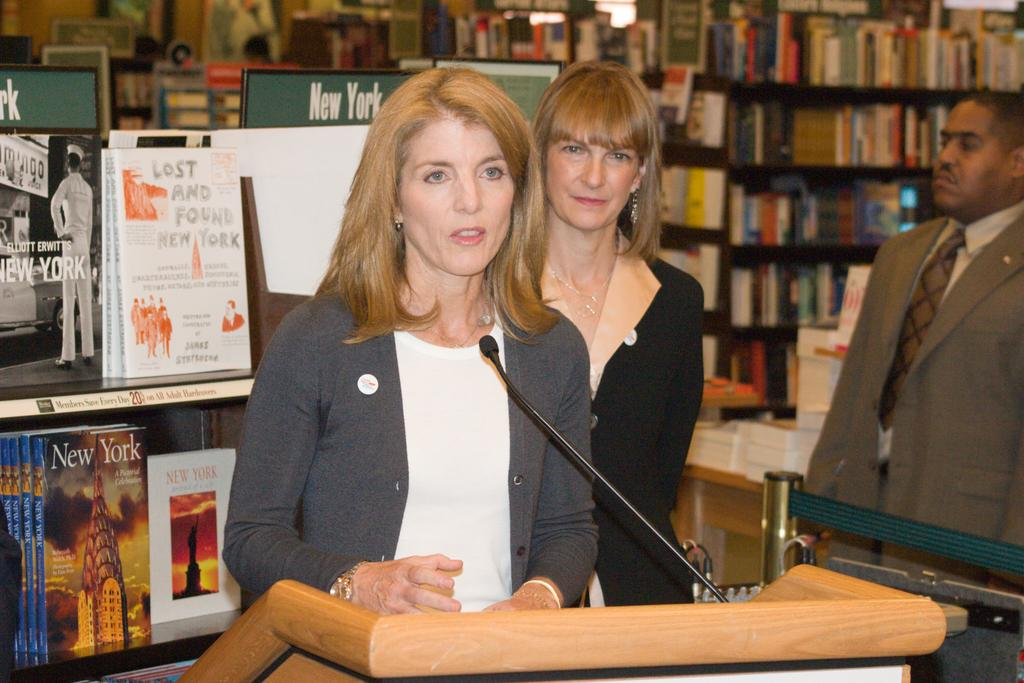How many people are in the foreground of the image? There are three persons standing in the foreground of the image. What surface are the persons standing on? The persons are standing on the floor. What can be seen in the background of the image? There are cupboards in the background of the image. What items are stored in the cupboards? Books are present in the cupboards. What type of location might the image represent? The image may have been taken in a library, given the presence of cupboards and books. What type of ink can be seen spilled on the marble floor in the image? There is no ink or marble floor present in the image; it features three persons standing on a floor with cupboards and books in the background. 